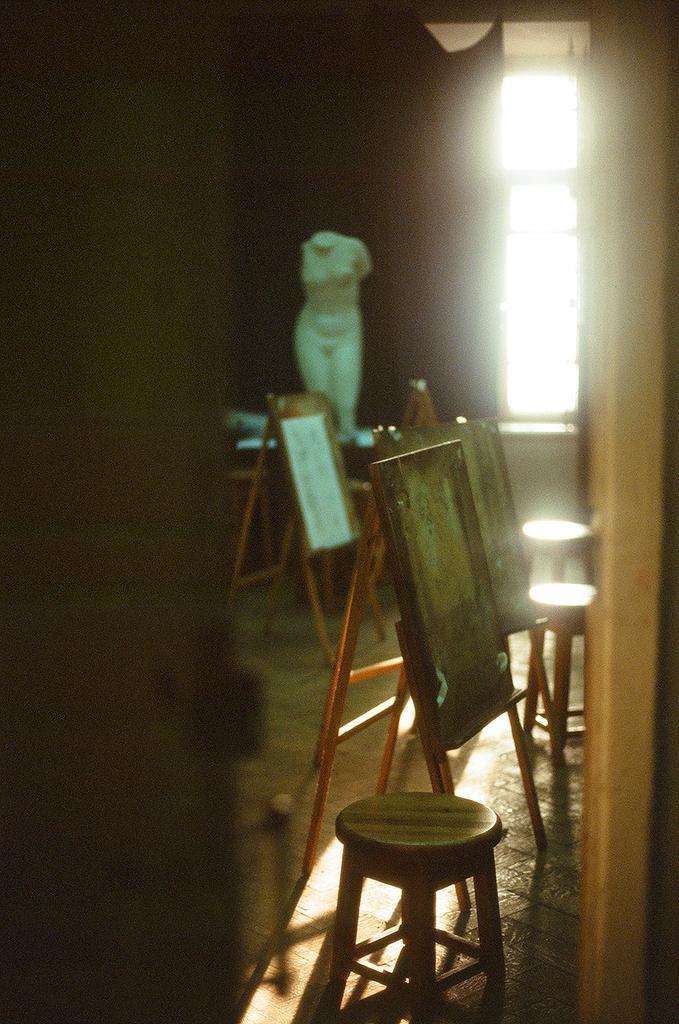Please provide a concise description of this image. In this picture we can see stools, boards, statue on the floor, window and in the background it is dark. 